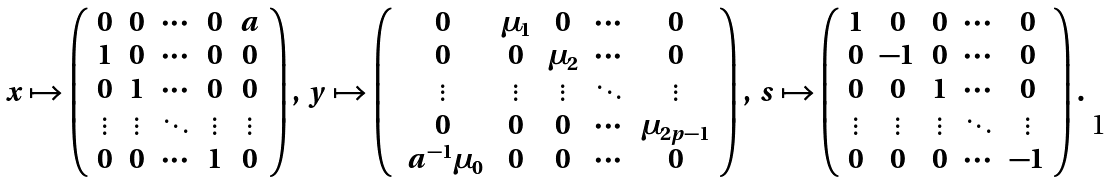Convert formula to latex. <formula><loc_0><loc_0><loc_500><loc_500>\ x \mapsto \left ( \begin{array} { c c c c c } 0 & 0 & \cdots & 0 & a \\ 1 & 0 & \cdots & 0 & 0 \\ 0 & 1 & \cdots & 0 & 0 \\ \vdots & \vdots & \ddots & \vdots & \vdots \\ 0 & 0 & \cdots & 1 & 0 \end{array} \right ) , \ y \mapsto \left ( \begin{array} { c c c c c } 0 & \mu _ { 1 } & 0 & \cdots & 0 \\ 0 & 0 & \mu _ { 2 } & \cdots & 0 \\ \vdots & \vdots & \vdots & \ddots & \vdots \\ 0 & 0 & 0 & \cdots & \mu _ { 2 p - 1 } \\ \ a ^ { - 1 } \mu _ { 0 } & 0 & 0 & \cdots & 0 \end{array} \right ) , \ s \mapsto \left ( \begin{array} { c c c c c } 1 & 0 & 0 & \cdots & 0 \\ 0 & - 1 & 0 & \cdots & 0 \\ 0 & 0 & 1 & \cdots & 0 \\ \vdots & \vdots & \vdots & \ddots & \vdots \\ 0 & 0 & 0 & \cdots & - 1 \end{array} \right ) .</formula> 